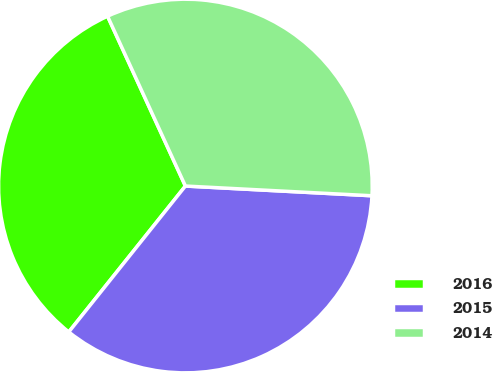Convert chart. <chart><loc_0><loc_0><loc_500><loc_500><pie_chart><fcel>2016<fcel>2015<fcel>2014<nl><fcel>32.43%<fcel>34.9%<fcel>32.67%<nl></chart> 